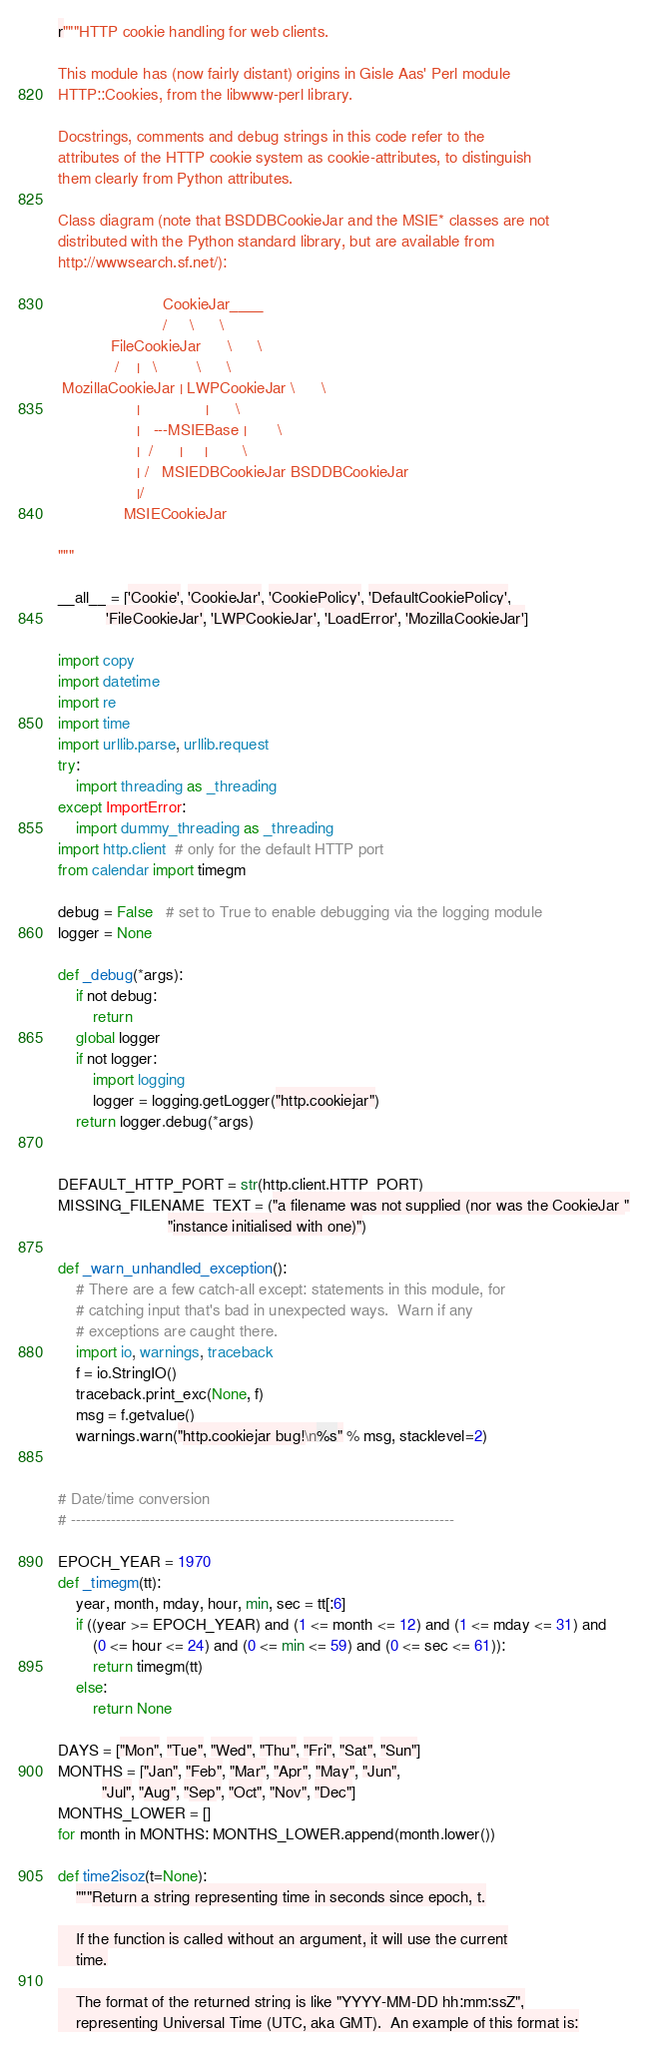Convert code to text. <code><loc_0><loc_0><loc_500><loc_500><_Python_>r"""HTTP cookie handling for web clients.

This module has (now fairly distant) origins in Gisle Aas' Perl module
HTTP::Cookies, from the libwww-perl library.

Docstrings, comments and debug strings in this code refer to the
attributes of the HTTP cookie system as cookie-attributes, to distinguish
them clearly from Python attributes.

Class diagram (note that BSDDBCookieJar and the MSIE* classes are not
distributed with the Python standard library, but are available from
http://wwwsearch.sf.net/):

                        CookieJar____
                        /     \      \
            FileCookieJar      \      \
             /    |   \         \      \
 MozillaCookieJar | LWPCookieJar \      \
                  |               |      \
                  |   ---MSIEBase |       \
                  |  /      |     |        \
                  | /   MSIEDBCookieJar BSDDBCookieJar
                  |/
               MSIECookieJar

"""

__all__ = ['Cookie', 'CookieJar', 'CookiePolicy', 'DefaultCookiePolicy',
           'FileCookieJar', 'LWPCookieJar', 'LoadError', 'MozillaCookieJar']

import copy
import datetime
import re
import time
import urllib.parse, urllib.request
try:
    import threading as _threading
except ImportError:
    import dummy_threading as _threading
import http.client  # only for the default HTTP port
from calendar import timegm

debug = False   # set to True to enable debugging via the logging module
logger = None

def _debug(*args):
    if not debug:
        return
    global logger
    if not logger:
        import logging
        logger = logging.getLogger("http.cookiejar")
    return logger.debug(*args)


DEFAULT_HTTP_PORT = str(http.client.HTTP_PORT)
MISSING_FILENAME_TEXT = ("a filename was not supplied (nor was the CookieJar "
                         "instance initialised with one)")

def _warn_unhandled_exception():
    # There are a few catch-all except: statements in this module, for
    # catching input that's bad in unexpected ways.  Warn if any
    # exceptions are caught there.
    import io, warnings, traceback
    f = io.StringIO()
    traceback.print_exc(None, f)
    msg = f.getvalue()
    warnings.warn("http.cookiejar bug!\n%s" % msg, stacklevel=2)


# Date/time conversion
# -----------------------------------------------------------------------------

EPOCH_YEAR = 1970
def _timegm(tt):
    year, month, mday, hour, min, sec = tt[:6]
    if ((year >= EPOCH_YEAR) and (1 <= month <= 12) and (1 <= mday <= 31) and
        (0 <= hour <= 24) and (0 <= min <= 59) and (0 <= sec <= 61)):
        return timegm(tt)
    else:
        return None

DAYS = ["Mon", "Tue", "Wed", "Thu", "Fri", "Sat", "Sun"]
MONTHS = ["Jan", "Feb", "Mar", "Apr", "May", "Jun",
          "Jul", "Aug", "Sep", "Oct", "Nov", "Dec"]
MONTHS_LOWER = []
for month in MONTHS: MONTHS_LOWER.append(month.lower())

def time2isoz(t=None):
    """Return a string representing time in seconds since epoch, t.

    If the function is called without an argument, it will use the current
    time.

    The format of the returned string is like "YYYY-MM-DD hh:mm:ssZ",
    representing Universal Time (UTC, aka GMT).  An example of this format is:
</code> 